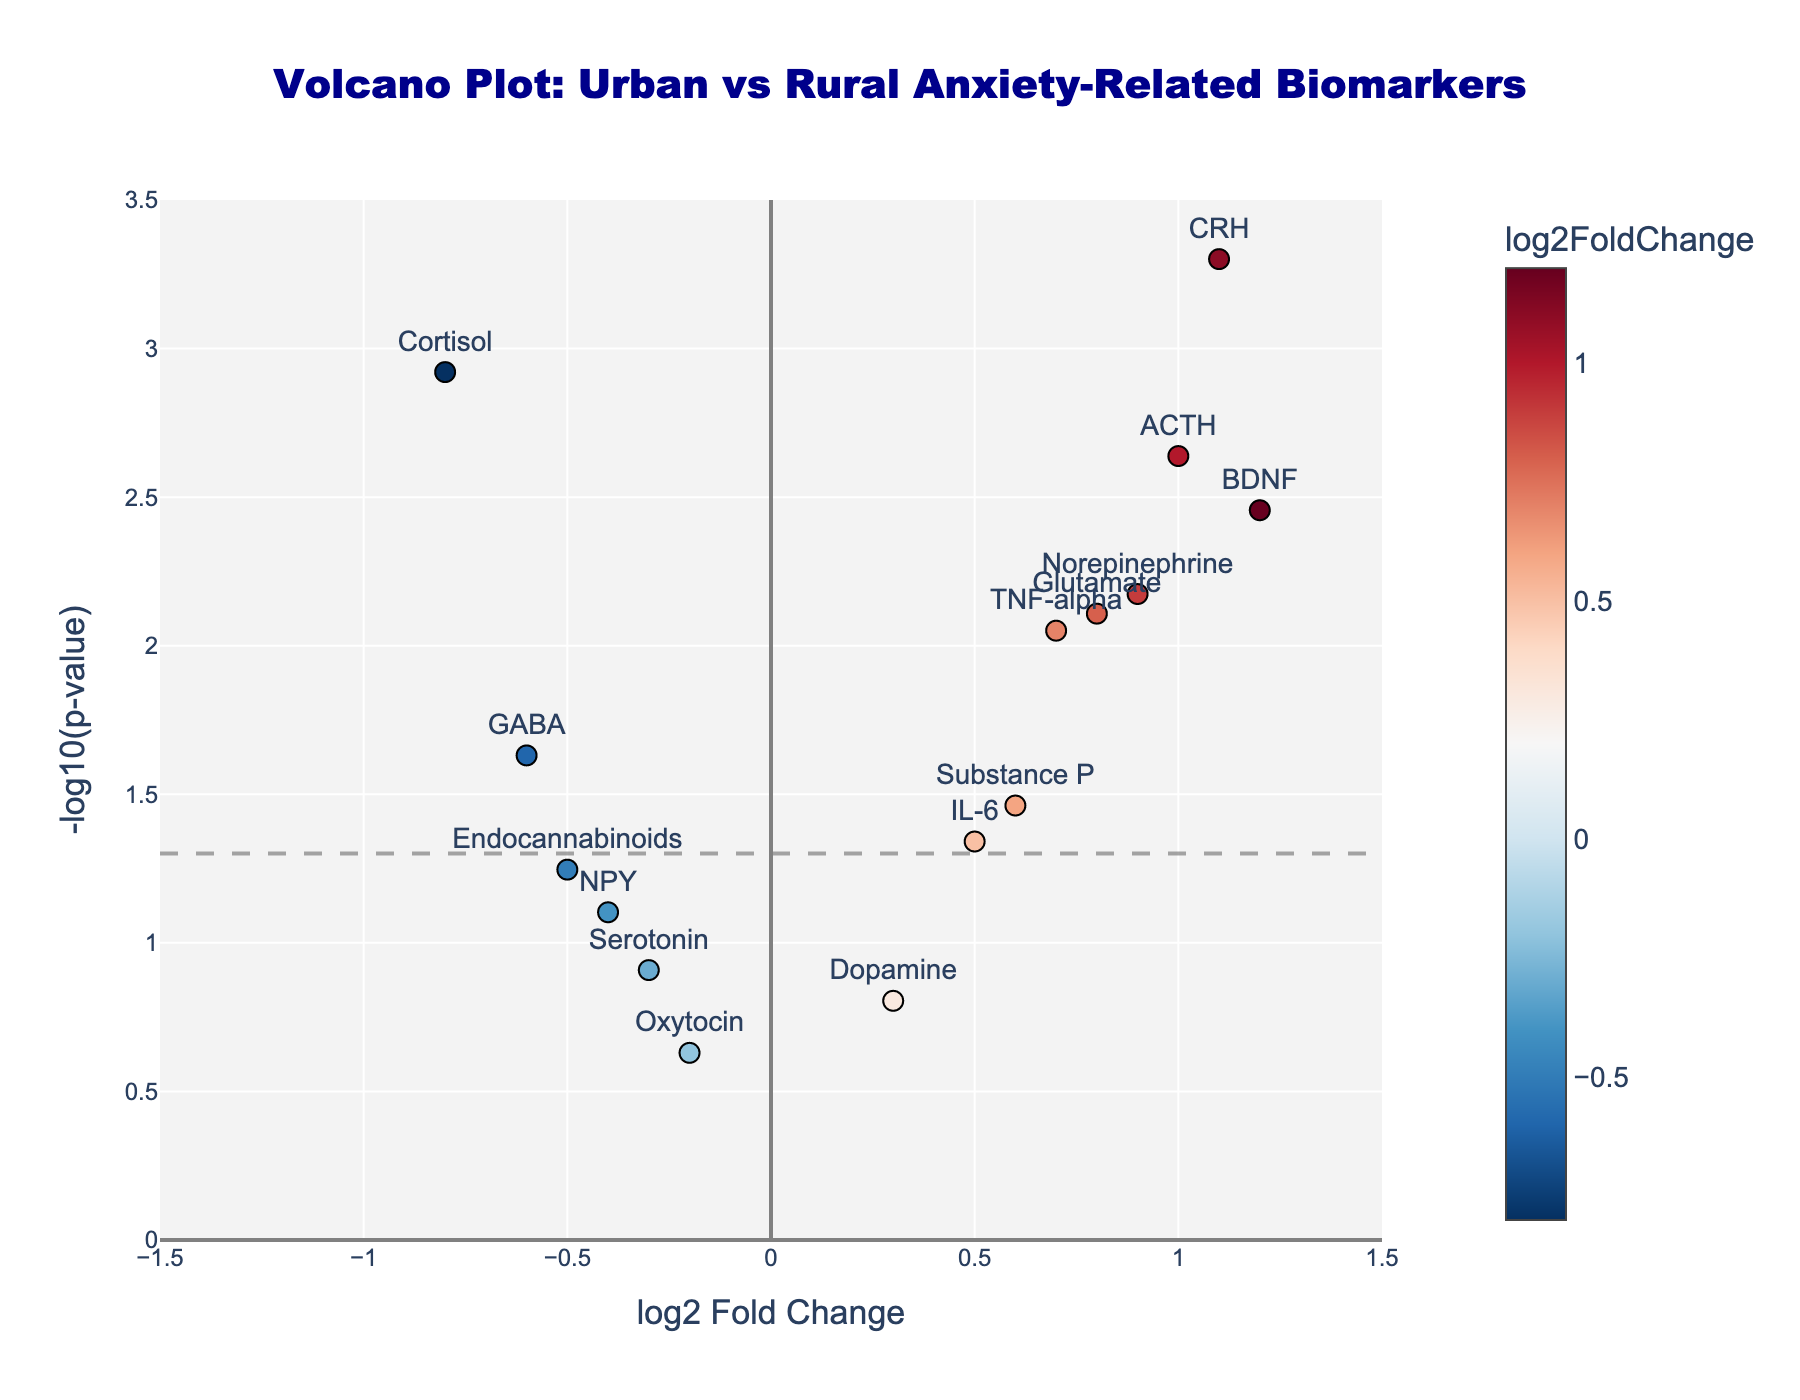What is the title of the figure? The title is usually placed at the top of the figure and is intended to describe the main focus of the plot. In this case, the title is at the center top.
Answer: "Volcano Plot: Urban vs Rural Anxiety-Related Biomarkers" How many genes have statistically significant differences? Statistically significant differences are typically defined as points above the horizontal dashed line (p-value = 0.05). Count the markers above this line.
Answer: 10 Which biomarkers are statistically significant with a positive log2 Fold Change? Look for markers above the horizontal threshold line and to the right of the vertical line (log2 Fold Change > 0). There are six such markers.
Answer: BDNF, TNF-alpha, Norepinephrine, CRH, Glutamate, ACTH Which biomarker has the highest log2 Fold Change? Identify the marker farthest to the right along the x-axis (log2 Fold Change). In this case, it is the marker with the maximum value.
Answer: BDNF with log2FC of 1.2 Which biomarker has the most significant p-value? Significance can be identified by the highest value on the y-axis (-log10(p-value)). Identify the marker that is highest up the y-axis.
Answer: CRH with log2FC of 1.1 and p-value of 0.0005 What is the log2 Fold Change of GABA, and is it statistically significant? Find GABA on the plot and note its x-coordinate (log2 Fold Change) and whether it is above the p-value threshold line.
Answer: -0.6, statistically significant Do any biomarkers have a log2 Fold Change less than 0 but are not statistically significant? Identify markers left of the vertical line (log2 Fold Change < 0) and below the horizontal threshold line (not significant).
Answer: Serotonin, Oxytocin, NPY, Endocannabinoids What is the p-value of Cortisol and is it higher or lower than the threshold of 0.05? Look for Cortisol and check its y-coordinate value. Compare this to the threshold line of -log10(0.05).
Answer: 0.0012, lower Between Cortisol and ACTH, which biomarker has a more significant p-value? Compare the y-coordinates of Cortisol and ACTH since p-value significance increases with higher y-values in -log10(p-value).
Answer: Cortisol with p-value of 0.0012 Which biomarkers have similar log2 Fold Changes but differ significantly in p-value? Look for markers with similar x-coordinates but differing y-coordinates significantly.
Answer: TNF-alpha, IL-6 